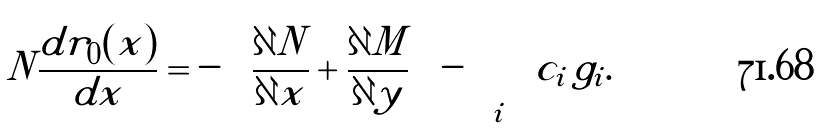<formula> <loc_0><loc_0><loc_500><loc_500>N \frac { d r _ { 0 } ( x ) } { d x } = - \left ( { \frac { \partial N } { \partial x } } + { \frac { \partial M } { \partial y } } \right ) - \sum _ { i } { c _ { i } \, g _ { i } } .</formula> 